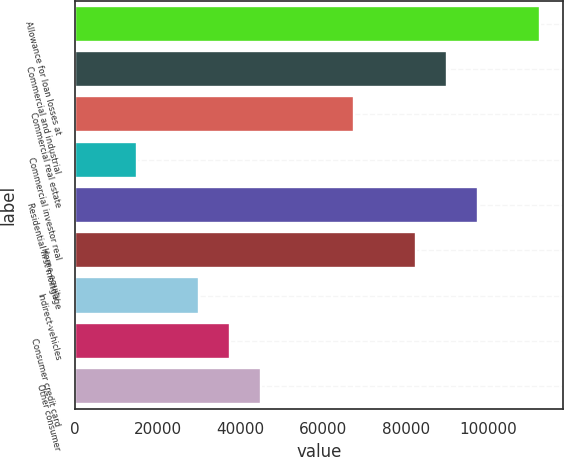Convert chart. <chart><loc_0><loc_0><loc_500><loc_500><bar_chart><fcel>Allowance for loan losses at<fcel>Commercial and industrial<fcel>Commercial real estate<fcel>Commercial investor real<fcel>Residential first mortgage<fcel>Home equity<fcel>Indirect-vehicles<fcel>Consumer credit card<fcel>Other consumer<nl><fcel>112385<fcel>89908.6<fcel>67431.7<fcel>14985.6<fcel>97400.9<fcel>82416.3<fcel>29970.2<fcel>37462.5<fcel>44954.8<nl></chart> 